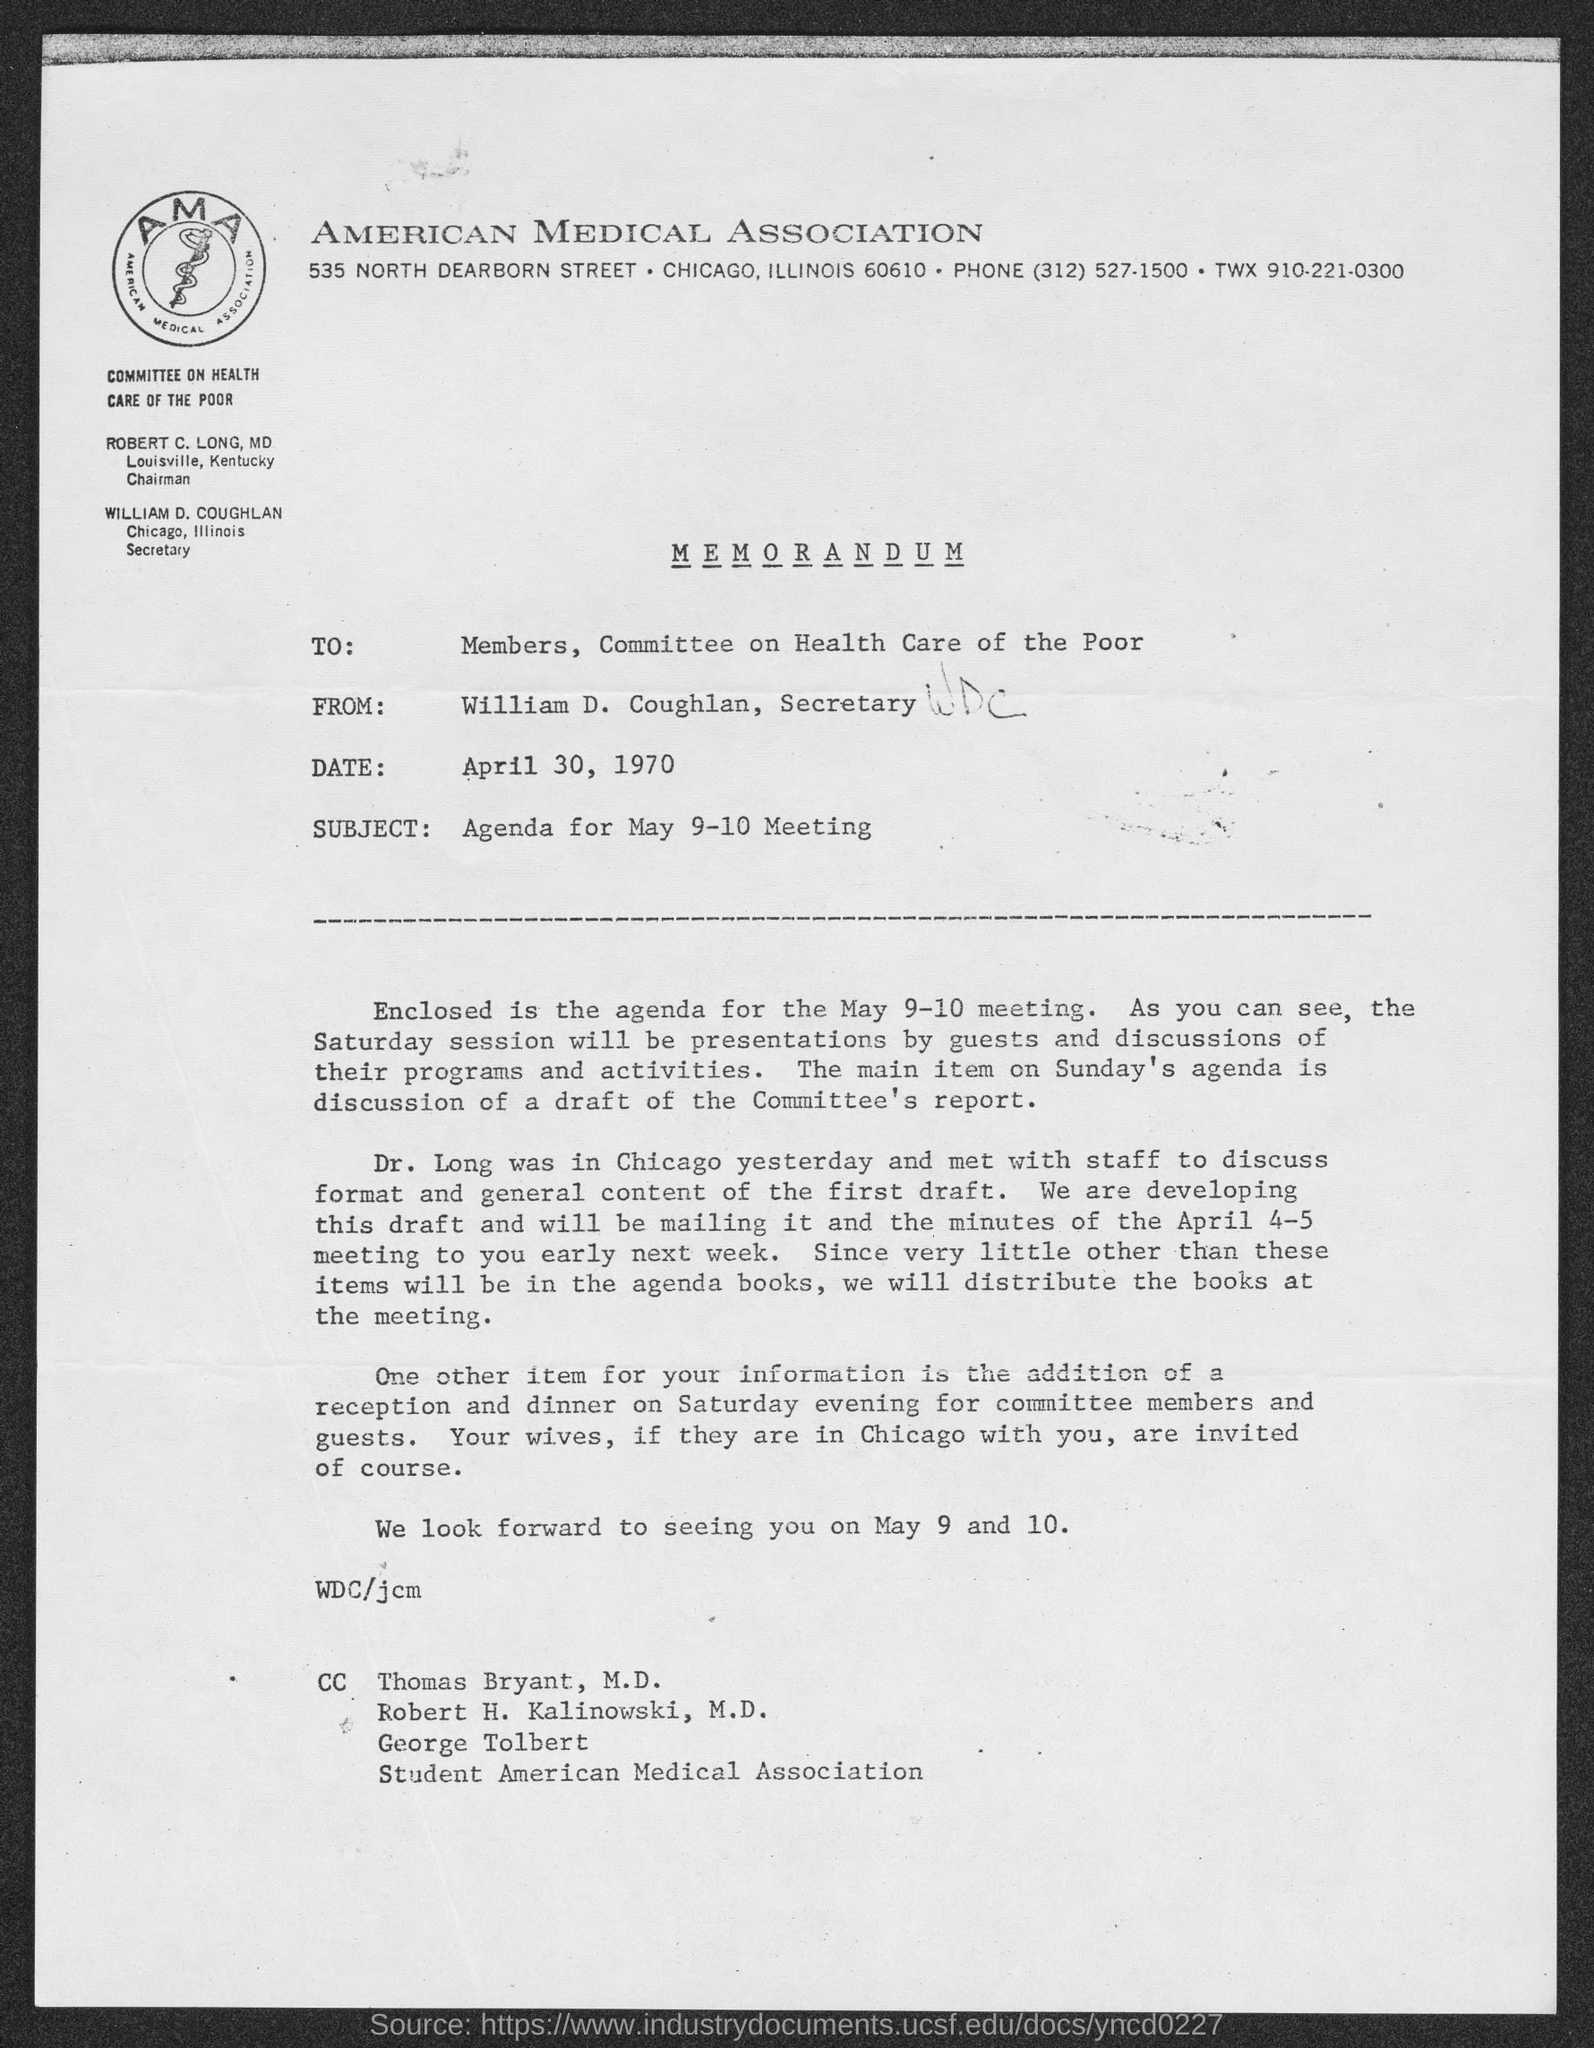Outline some significant characteristics in this image. The subject mentioned in the memorandum is the agenda for the May 9-10 meeting. The sender of this memorandum is William D. Coughlan, Secretary. The date mentioned in this memorandum is April 30, 1970. The communication in question is a memorandum. The recipient(s) of this memorandum are the members of the committee on health care for the poor. 